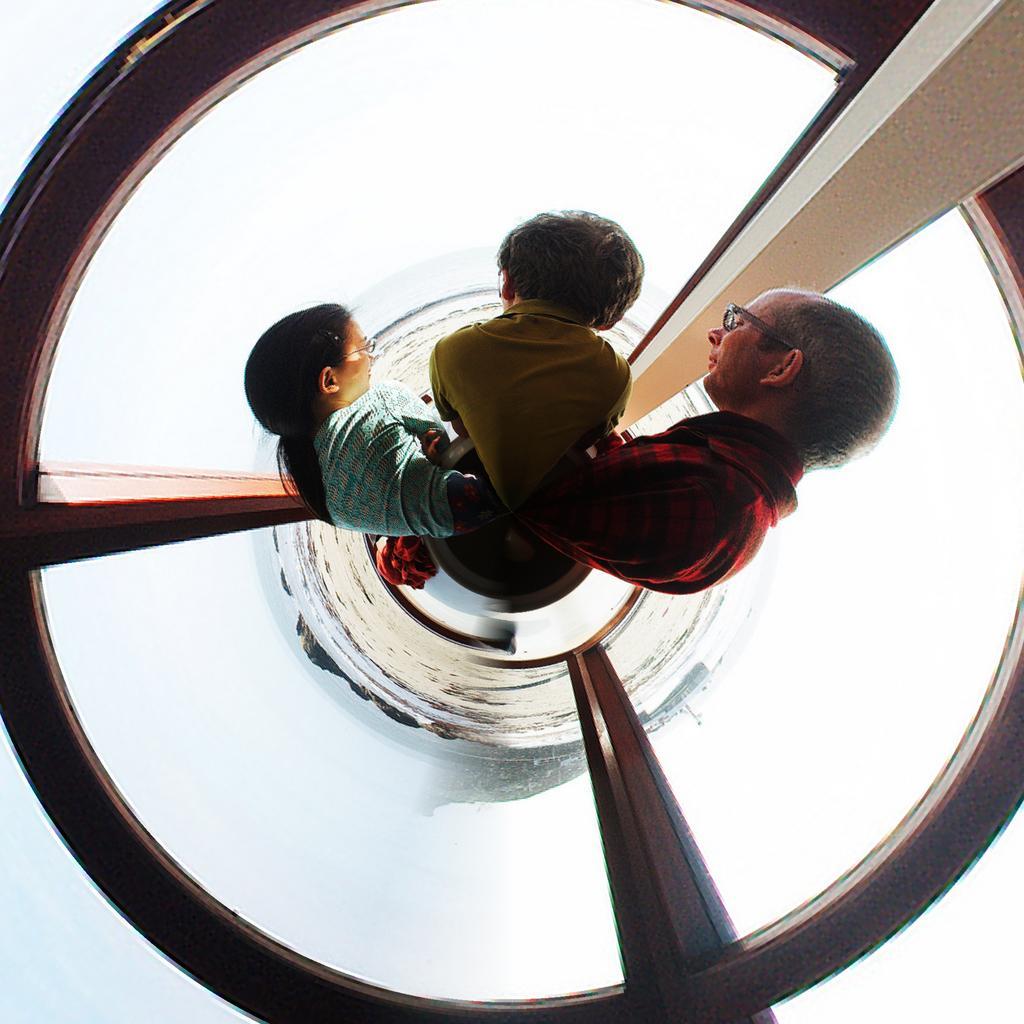Please provide a concise description of this image. This image is taken from the top angle. In this image there are three people standing in a cylindrical glass structure with wooden poles. 